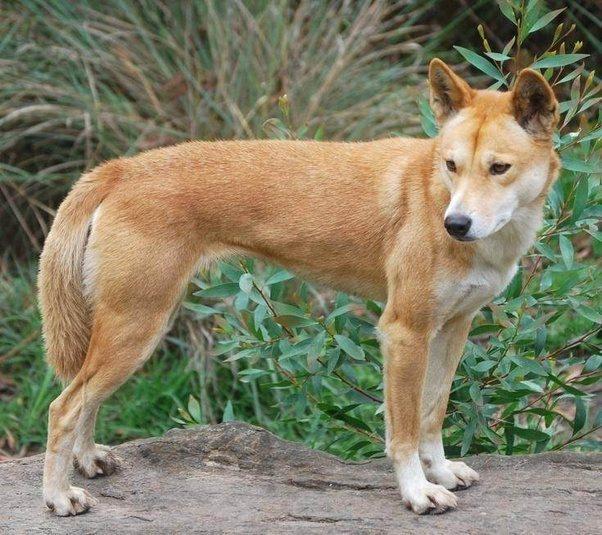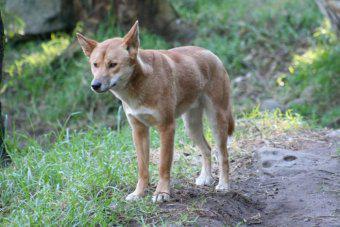The first image is the image on the left, the second image is the image on the right. Assess this claim about the two images: "An image shows at least one dog looking completely to the side.". Correct or not? Answer yes or no. No. 